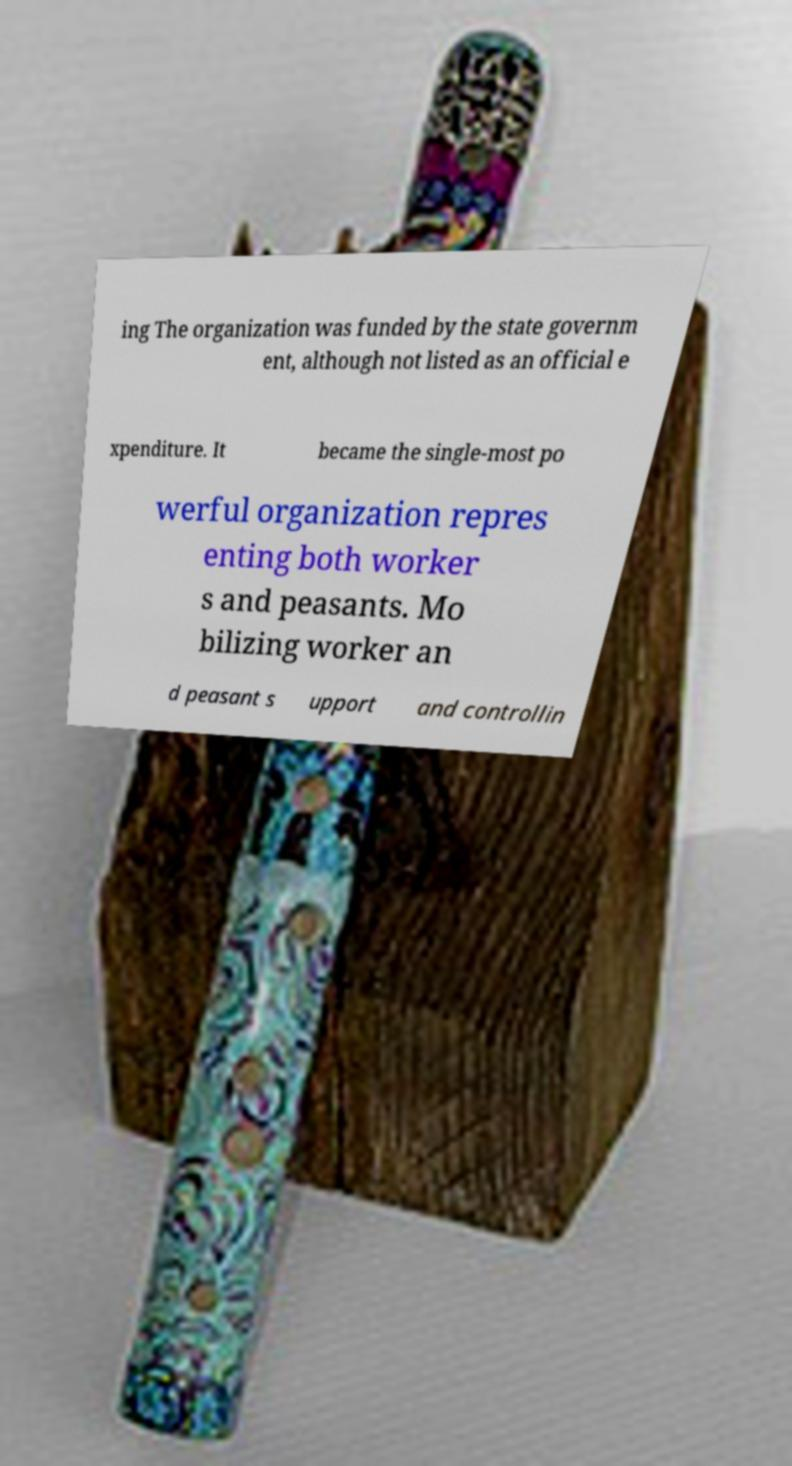Please read and relay the text visible in this image. What does it say? ing The organization was funded by the state governm ent, although not listed as an official e xpenditure. It became the single-most po werful organization repres enting both worker s and peasants. Mo bilizing worker an d peasant s upport and controllin 